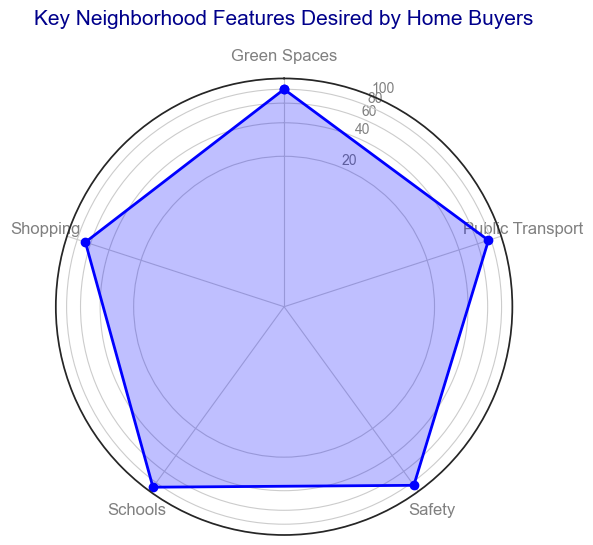What feature has the highest average value? By inspecting the radar chart, we can identify the feature with the largest area. The point at the highest value on the radial axis indicates the feature with the highest average value. Schools peak at 87.8, the highest among all features.
Answer: Schools What is the average value of Safety and Green Spaces combined? First, identify the average values for Safety and Green Spaces from the radar chart, which are approximately 85.6 and 80 respectively. Then, calculate the combined average: (85.6 + 80) / 2 = 82.8.
Answer: 82.8 Which feature has more spread, Public Transport or Shopping? By examining the radar chart, compare the data points' extent away from the center for Public Transport and Shopping. Public Transport's range (70 to 80) is smaller compared to Shopping (60 to 72), indicating Shopping has more spread.
Answer: Shopping Is the value for Public Transport higher or lower than the value for Safety? Compare the plotted points for Public Transport and Safety along the radial axes; the chart shows that the Public Transport average value (~75.8) is lower than that of Safety (~85.6).
Answer: Lower How many features have average values above 80? Inspect the radar chart to count the features where data points extend past the 80 mark on the radial axes. Safety, Schools, and Green Spaces have average values above 80, totaling to three.
Answer: 3 